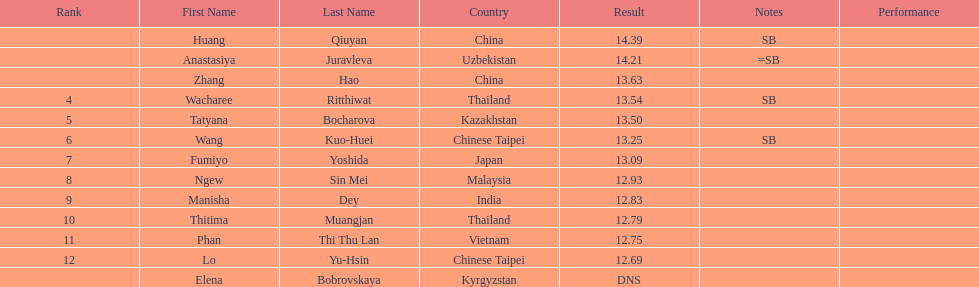How many athletes had a better result than tatyana bocharova? 4. 